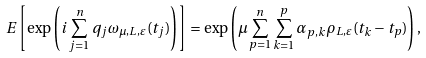Convert formula to latex. <formula><loc_0><loc_0><loc_500><loc_500>{ E } \left [ \exp \left ( i \sum _ { j = 1 } ^ { n } q _ { j } \omega _ { \mu , L , \varepsilon } ( t _ { j } ) \right ) \right ] = \exp \left ( \mu \sum _ { p = 1 } ^ { n } \sum _ { k = 1 } ^ { p } \alpha _ { p , k } \rho _ { L , \varepsilon } ( t _ { k } - t _ { p } ) \right ) ,</formula> 